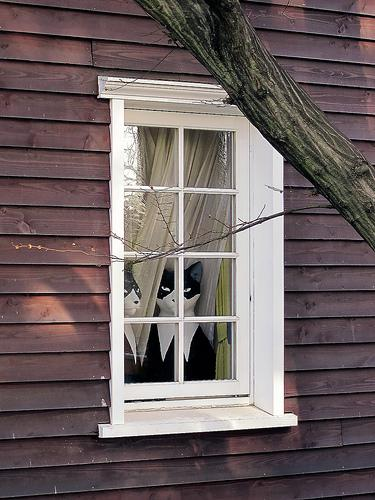Question: where was the picture taken?
Choices:
A. A bathroom.
B. A farm.
C. An office.
D. From outside.
Answer with the letter. Answer: D Question: when has pointy ears?
Choices:
A. The dog.
B. The cat.
C. The wizard.
D. The cartoon character.
Answer with the letter. Answer: B Question: what is black and white?
Choices:
A. Tv.
B. Car.
C. Cat.
D. Picture.
Answer with the letter. Answer: C Question: why is a cat at the window sill?
Choices:
A. Getting ready to jump out.
B. It's sad.
C. Looking out the window.
D. Getting ready to get down.
Answer with the letter. Answer: C Question: what is white?
Choices:
A. Car.
B. Paper.
C. Window.
D. Wall.
Answer with the letter. Answer: C 